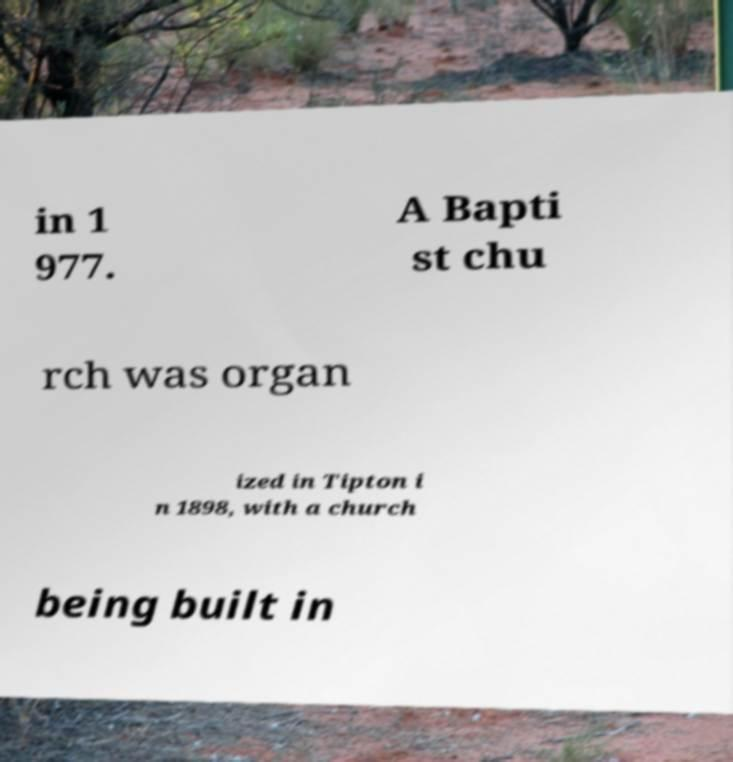Could you extract and type out the text from this image? in 1 977. A Bapti st chu rch was organ ized in Tipton i n 1898, with a church being built in 